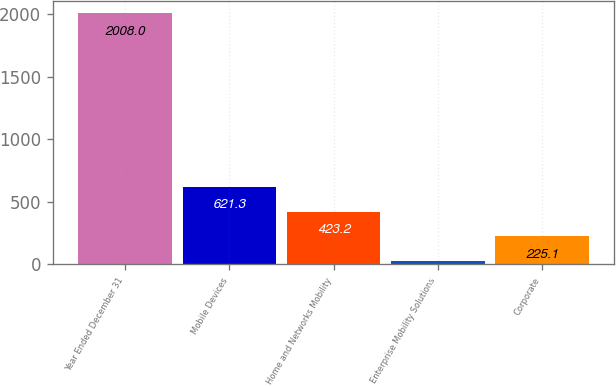<chart> <loc_0><loc_0><loc_500><loc_500><bar_chart><fcel>Year Ended December 31<fcel>Mobile Devices<fcel>Home and Networks Mobility<fcel>Enterprise Mobility Solutions<fcel>Corporate<nl><fcel>2008<fcel>621.3<fcel>423.2<fcel>27<fcel>225.1<nl></chart> 